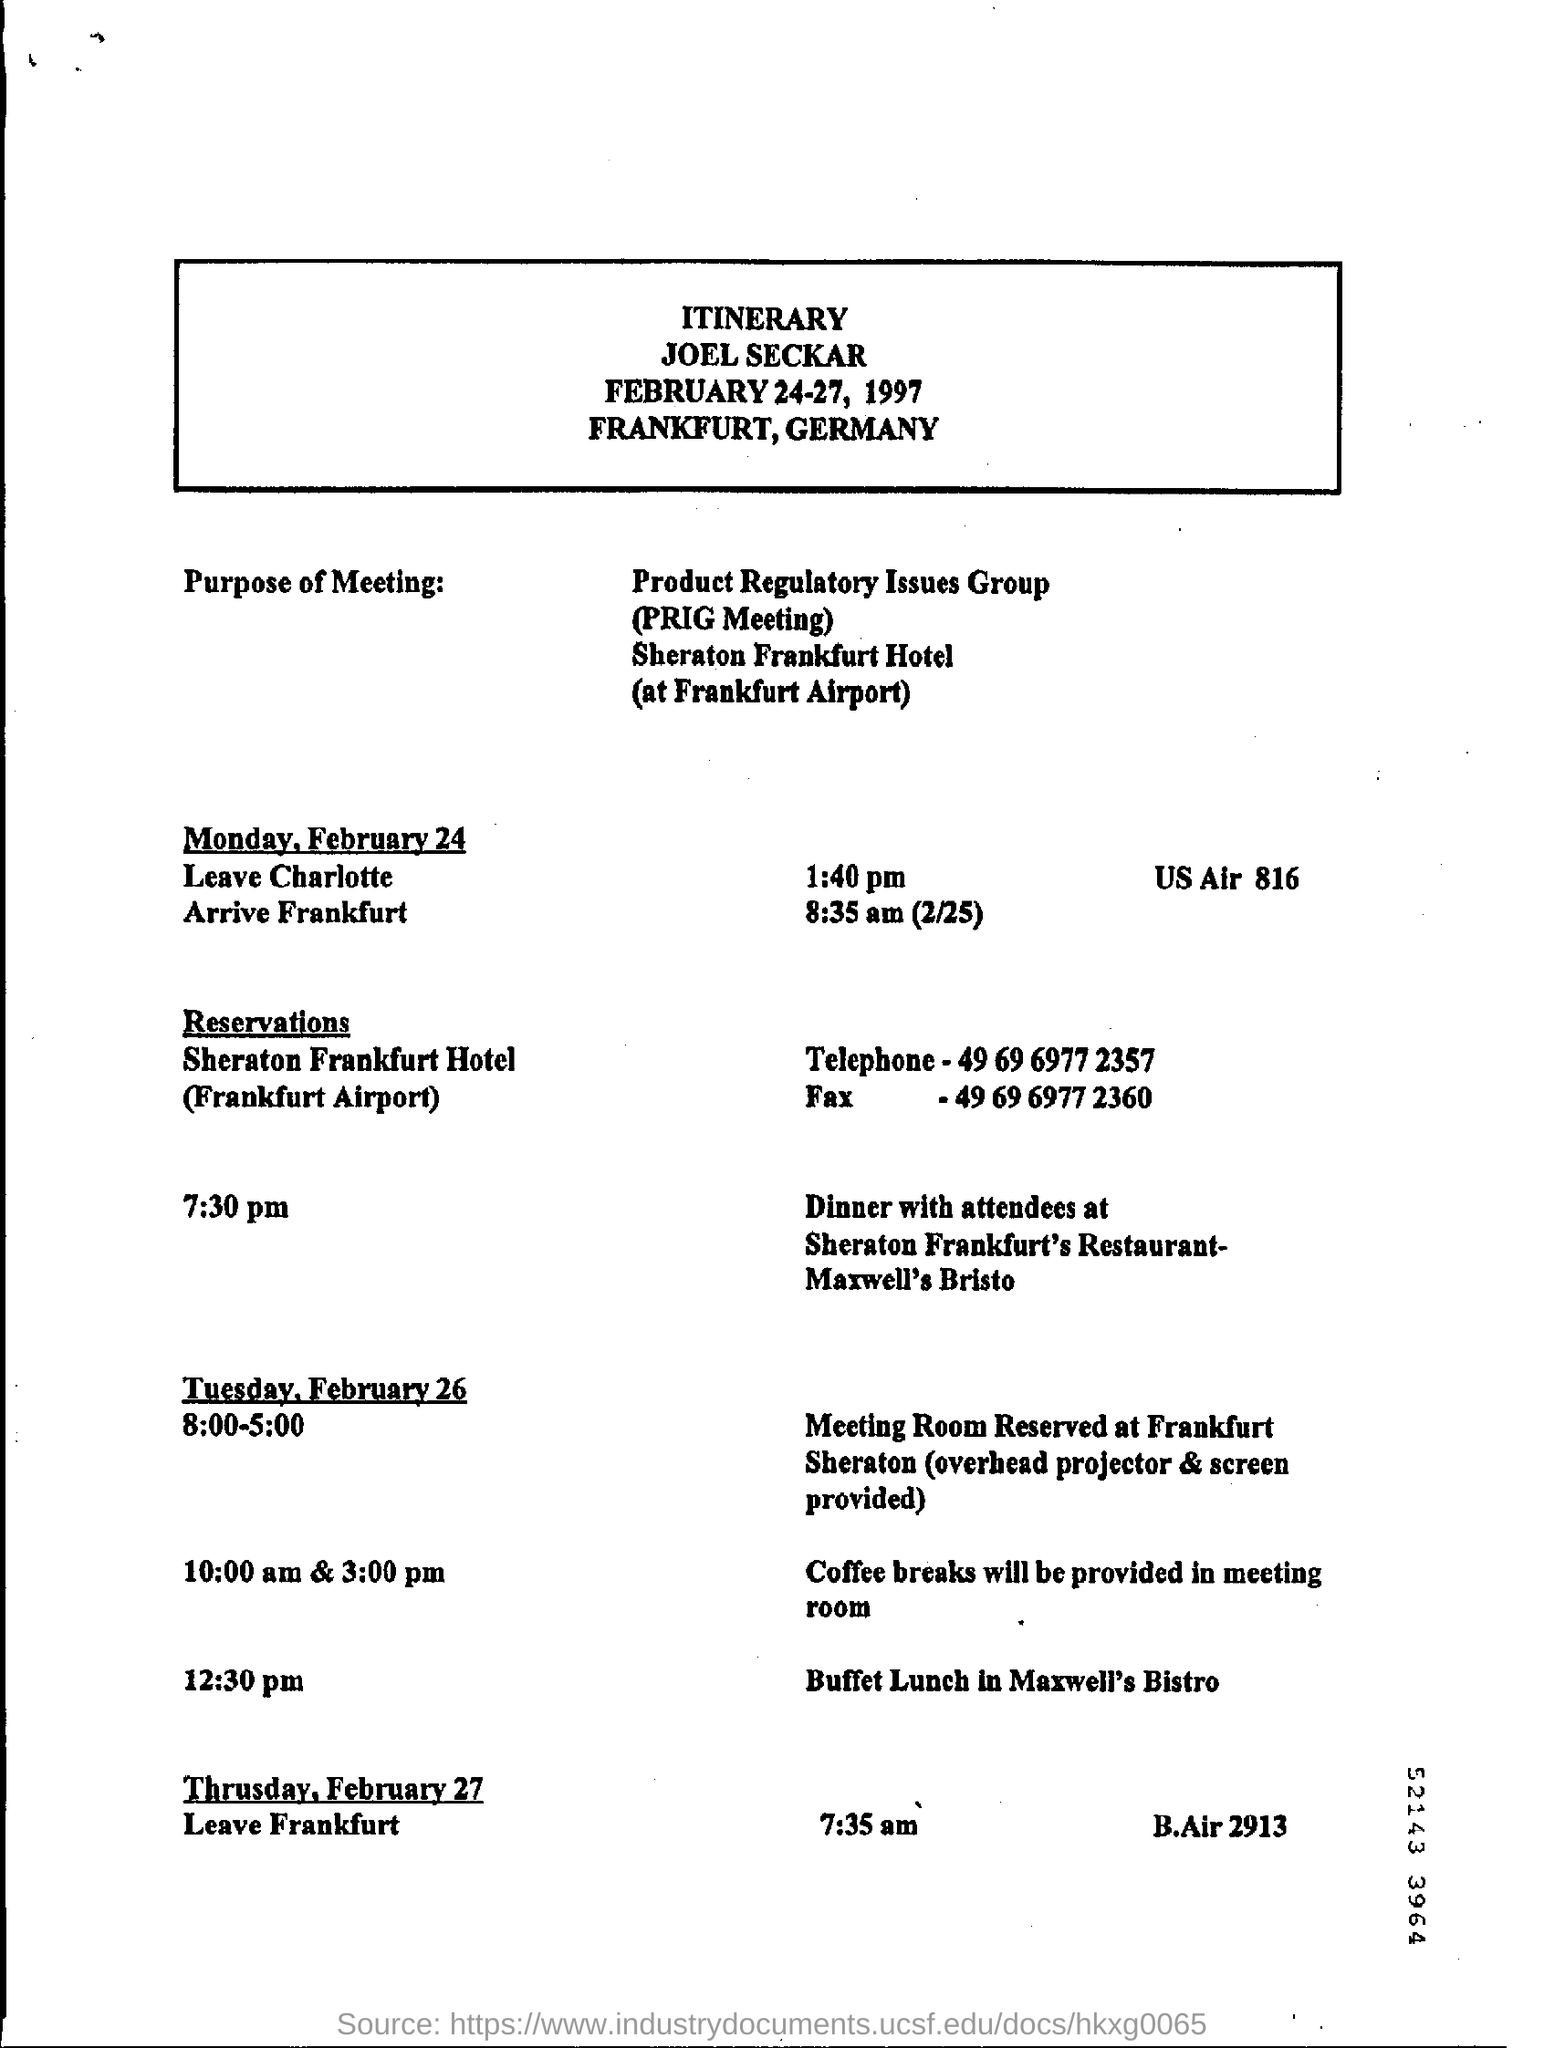What is the fullform of PRIG?
Offer a terse response. Product Regulatory Issues Group. What is the time mentioned to leave Charlotte?
Your answer should be very brief. 1:40 pm. What is the time mentioned to leave Frankfurt?
Offer a very short reply. 7.35 am. Where is Frankfurt located?
Provide a short and direct response. Germany. At what time is dinner with attendees at Maxwell's Bristo
Keep it short and to the point. 7.30 pm. Where is Sheraton Frankfurt located?
Offer a very short reply. Frankfurt Airport. Where is the buffet lunch arranged?
Your answer should be very brief. Maxwell's Bistro. 